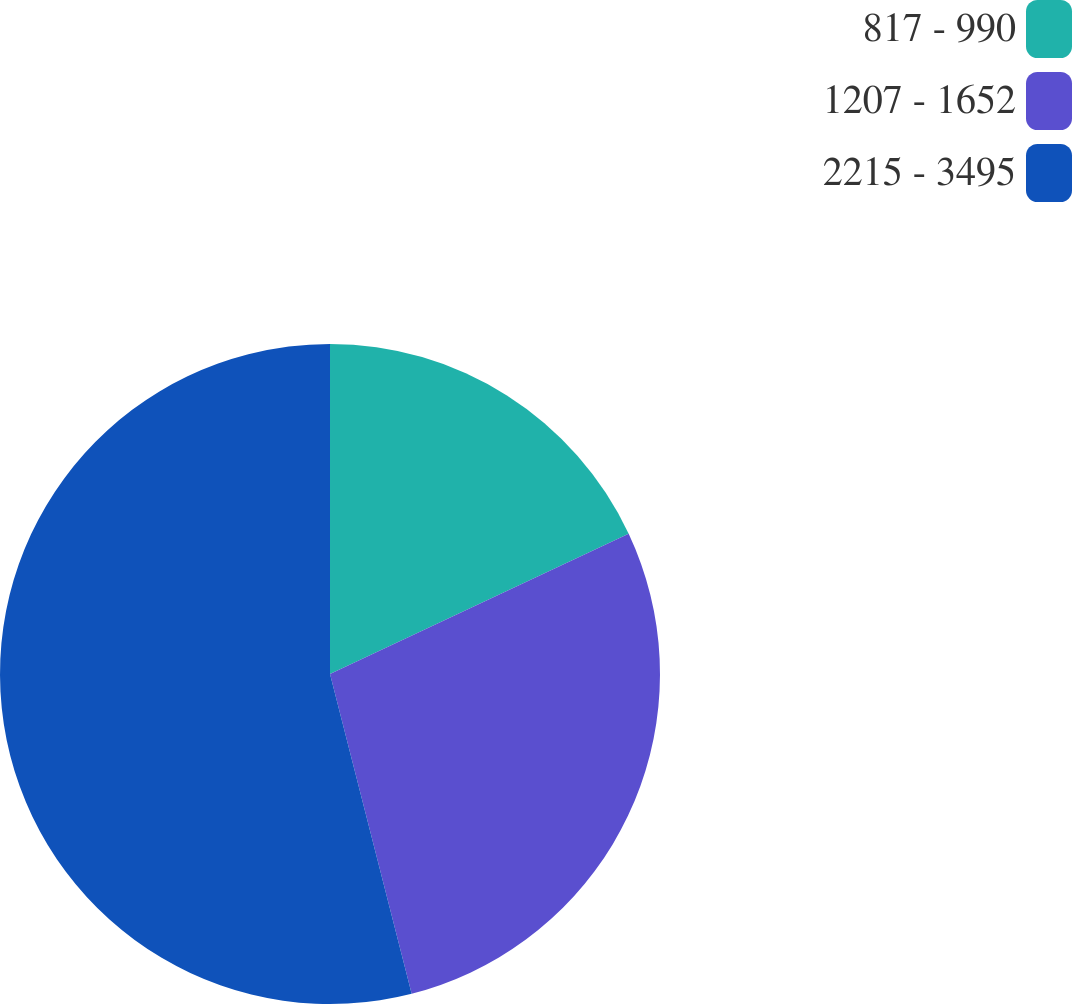<chart> <loc_0><loc_0><loc_500><loc_500><pie_chart><fcel>817 - 990<fcel>1207 - 1652<fcel>2215 - 3495<nl><fcel>18.01%<fcel>28.01%<fcel>53.98%<nl></chart> 